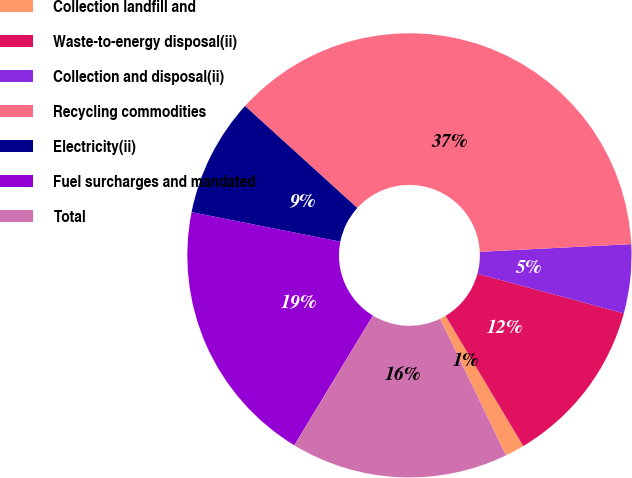<chart> <loc_0><loc_0><loc_500><loc_500><pie_chart><fcel>Collection landfill and<fcel>Waste-to-energy disposal(ii)<fcel>Collection and disposal(ii)<fcel>Recycling commodities<fcel>Electricity(ii)<fcel>Fuel surcharges and mandated<fcel>Total<nl><fcel>1.41%<fcel>12.23%<fcel>5.01%<fcel>37.46%<fcel>8.62%<fcel>19.44%<fcel>15.83%<nl></chart> 